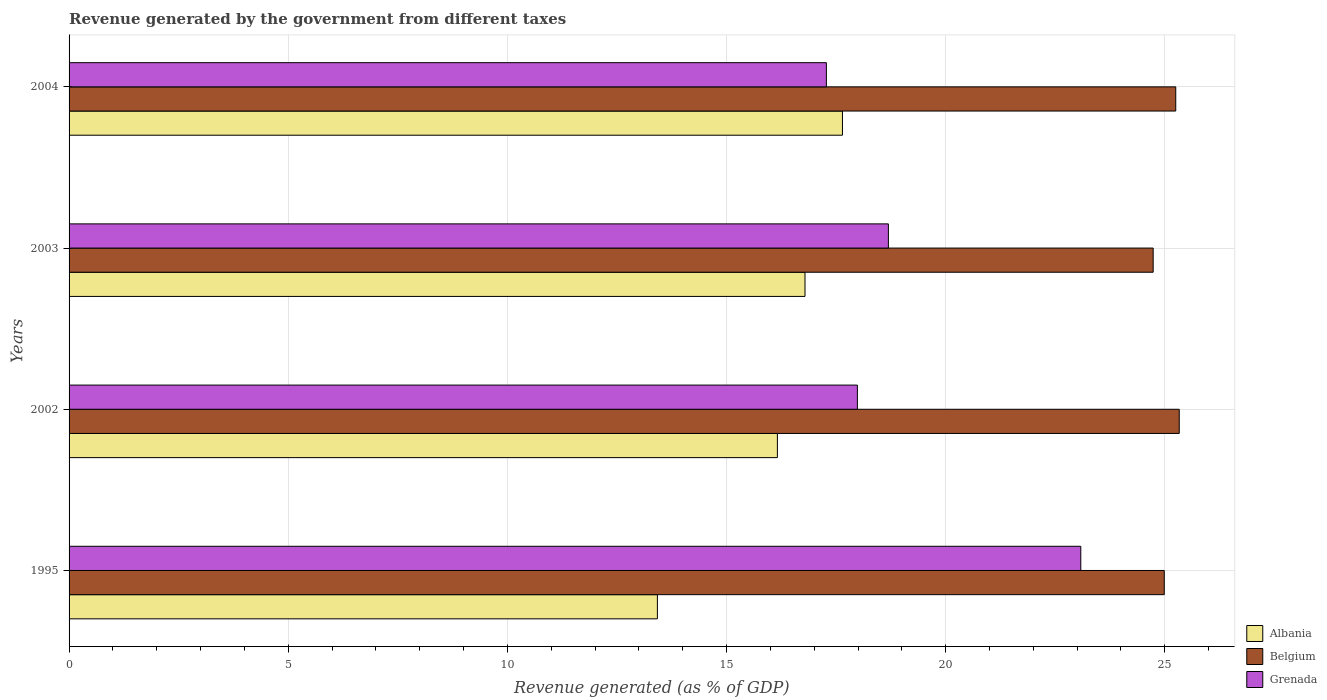How many groups of bars are there?
Offer a very short reply. 4. Are the number of bars per tick equal to the number of legend labels?
Provide a short and direct response. Yes. How many bars are there on the 3rd tick from the top?
Make the answer very short. 3. How many bars are there on the 4th tick from the bottom?
Your answer should be compact. 3. What is the label of the 2nd group of bars from the top?
Provide a succinct answer. 2003. What is the revenue generated by the government in Belgium in 2003?
Your response must be concise. 24.73. Across all years, what is the maximum revenue generated by the government in Grenada?
Keep it short and to the point. 23.08. Across all years, what is the minimum revenue generated by the government in Grenada?
Ensure brevity in your answer.  17.28. In which year was the revenue generated by the government in Belgium maximum?
Ensure brevity in your answer.  2002. What is the total revenue generated by the government in Albania in the graph?
Your response must be concise. 64.02. What is the difference between the revenue generated by the government in Grenada in 1995 and that in 2004?
Your answer should be very brief. 5.8. What is the difference between the revenue generated by the government in Albania in 2004 and the revenue generated by the government in Grenada in 2003?
Offer a very short reply. -1.05. What is the average revenue generated by the government in Grenada per year?
Your answer should be compact. 19.26. In the year 2002, what is the difference between the revenue generated by the government in Albania and revenue generated by the government in Belgium?
Provide a succinct answer. -9.17. In how many years, is the revenue generated by the government in Grenada greater than 2 %?
Give a very brief answer. 4. What is the ratio of the revenue generated by the government in Grenada in 2003 to that in 2004?
Offer a terse response. 1.08. What is the difference between the highest and the second highest revenue generated by the government in Belgium?
Your answer should be compact. 0.08. What is the difference between the highest and the lowest revenue generated by the government in Albania?
Make the answer very short. 4.22. Is the sum of the revenue generated by the government in Albania in 1995 and 2003 greater than the maximum revenue generated by the government in Belgium across all years?
Your response must be concise. Yes. What does the 1st bar from the top in 2002 represents?
Make the answer very short. Grenada. How many bars are there?
Make the answer very short. 12. How many years are there in the graph?
Your answer should be very brief. 4. What is the difference between two consecutive major ticks on the X-axis?
Your answer should be very brief. 5. Does the graph contain any zero values?
Your response must be concise. No. Does the graph contain grids?
Provide a succinct answer. Yes. How many legend labels are there?
Make the answer very short. 3. What is the title of the graph?
Your response must be concise. Revenue generated by the government from different taxes. What is the label or title of the X-axis?
Offer a very short reply. Revenue generated (as % of GDP). What is the Revenue generated (as % of GDP) in Albania in 1995?
Ensure brevity in your answer.  13.42. What is the Revenue generated (as % of GDP) of Belgium in 1995?
Offer a very short reply. 24.99. What is the Revenue generated (as % of GDP) in Grenada in 1995?
Ensure brevity in your answer.  23.08. What is the Revenue generated (as % of GDP) of Albania in 2002?
Ensure brevity in your answer.  16.16. What is the Revenue generated (as % of GDP) in Belgium in 2002?
Offer a very short reply. 25.33. What is the Revenue generated (as % of GDP) in Grenada in 2002?
Your answer should be very brief. 17.99. What is the Revenue generated (as % of GDP) in Albania in 2003?
Provide a short and direct response. 16.79. What is the Revenue generated (as % of GDP) in Belgium in 2003?
Ensure brevity in your answer.  24.73. What is the Revenue generated (as % of GDP) in Grenada in 2003?
Provide a short and direct response. 18.69. What is the Revenue generated (as % of GDP) of Albania in 2004?
Give a very brief answer. 17.65. What is the Revenue generated (as % of GDP) in Belgium in 2004?
Offer a terse response. 25.25. What is the Revenue generated (as % of GDP) in Grenada in 2004?
Your answer should be compact. 17.28. Across all years, what is the maximum Revenue generated (as % of GDP) of Albania?
Keep it short and to the point. 17.65. Across all years, what is the maximum Revenue generated (as % of GDP) of Belgium?
Make the answer very short. 25.33. Across all years, what is the maximum Revenue generated (as % of GDP) of Grenada?
Keep it short and to the point. 23.08. Across all years, what is the minimum Revenue generated (as % of GDP) of Albania?
Provide a succinct answer. 13.42. Across all years, what is the minimum Revenue generated (as % of GDP) of Belgium?
Give a very brief answer. 24.73. Across all years, what is the minimum Revenue generated (as % of GDP) in Grenada?
Ensure brevity in your answer.  17.28. What is the total Revenue generated (as % of GDP) of Albania in the graph?
Keep it short and to the point. 64.02. What is the total Revenue generated (as % of GDP) of Belgium in the graph?
Make the answer very short. 100.3. What is the total Revenue generated (as % of GDP) in Grenada in the graph?
Your response must be concise. 77.04. What is the difference between the Revenue generated (as % of GDP) of Albania in 1995 and that in 2002?
Offer a very short reply. -2.74. What is the difference between the Revenue generated (as % of GDP) of Belgium in 1995 and that in 2002?
Provide a short and direct response. -0.34. What is the difference between the Revenue generated (as % of GDP) of Grenada in 1995 and that in 2002?
Offer a terse response. 5.1. What is the difference between the Revenue generated (as % of GDP) of Albania in 1995 and that in 2003?
Ensure brevity in your answer.  -3.37. What is the difference between the Revenue generated (as % of GDP) of Belgium in 1995 and that in 2003?
Offer a very short reply. 0.25. What is the difference between the Revenue generated (as % of GDP) of Grenada in 1995 and that in 2003?
Provide a short and direct response. 4.39. What is the difference between the Revenue generated (as % of GDP) of Albania in 1995 and that in 2004?
Your response must be concise. -4.22. What is the difference between the Revenue generated (as % of GDP) in Belgium in 1995 and that in 2004?
Make the answer very short. -0.26. What is the difference between the Revenue generated (as % of GDP) in Grenada in 1995 and that in 2004?
Offer a terse response. 5.8. What is the difference between the Revenue generated (as % of GDP) of Albania in 2002 and that in 2003?
Your answer should be very brief. -0.63. What is the difference between the Revenue generated (as % of GDP) of Belgium in 2002 and that in 2003?
Your response must be concise. 0.59. What is the difference between the Revenue generated (as % of GDP) of Grenada in 2002 and that in 2003?
Your answer should be compact. -0.71. What is the difference between the Revenue generated (as % of GDP) in Albania in 2002 and that in 2004?
Your answer should be compact. -1.48. What is the difference between the Revenue generated (as % of GDP) in Belgium in 2002 and that in 2004?
Provide a short and direct response. 0.08. What is the difference between the Revenue generated (as % of GDP) of Grenada in 2002 and that in 2004?
Give a very brief answer. 0.71. What is the difference between the Revenue generated (as % of GDP) in Albania in 2003 and that in 2004?
Your answer should be very brief. -0.85. What is the difference between the Revenue generated (as % of GDP) of Belgium in 2003 and that in 2004?
Your response must be concise. -0.52. What is the difference between the Revenue generated (as % of GDP) of Grenada in 2003 and that in 2004?
Offer a very short reply. 1.41. What is the difference between the Revenue generated (as % of GDP) in Albania in 1995 and the Revenue generated (as % of GDP) in Belgium in 2002?
Give a very brief answer. -11.91. What is the difference between the Revenue generated (as % of GDP) of Albania in 1995 and the Revenue generated (as % of GDP) of Grenada in 2002?
Offer a very short reply. -4.56. What is the difference between the Revenue generated (as % of GDP) in Belgium in 1995 and the Revenue generated (as % of GDP) in Grenada in 2002?
Provide a succinct answer. 7. What is the difference between the Revenue generated (as % of GDP) in Albania in 1995 and the Revenue generated (as % of GDP) in Belgium in 2003?
Your answer should be very brief. -11.31. What is the difference between the Revenue generated (as % of GDP) in Albania in 1995 and the Revenue generated (as % of GDP) in Grenada in 2003?
Offer a terse response. -5.27. What is the difference between the Revenue generated (as % of GDP) of Belgium in 1995 and the Revenue generated (as % of GDP) of Grenada in 2003?
Provide a succinct answer. 6.29. What is the difference between the Revenue generated (as % of GDP) in Albania in 1995 and the Revenue generated (as % of GDP) in Belgium in 2004?
Make the answer very short. -11.83. What is the difference between the Revenue generated (as % of GDP) in Albania in 1995 and the Revenue generated (as % of GDP) in Grenada in 2004?
Your answer should be very brief. -3.86. What is the difference between the Revenue generated (as % of GDP) in Belgium in 1995 and the Revenue generated (as % of GDP) in Grenada in 2004?
Your response must be concise. 7.71. What is the difference between the Revenue generated (as % of GDP) in Albania in 2002 and the Revenue generated (as % of GDP) in Belgium in 2003?
Provide a short and direct response. -8.57. What is the difference between the Revenue generated (as % of GDP) in Albania in 2002 and the Revenue generated (as % of GDP) in Grenada in 2003?
Your answer should be compact. -2.53. What is the difference between the Revenue generated (as % of GDP) in Belgium in 2002 and the Revenue generated (as % of GDP) in Grenada in 2003?
Give a very brief answer. 6.64. What is the difference between the Revenue generated (as % of GDP) in Albania in 2002 and the Revenue generated (as % of GDP) in Belgium in 2004?
Provide a short and direct response. -9.09. What is the difference between the Revenue generated (as % of GDP) of Albania in 2002 and the Revenue generated (as % of GDP) of Grenada in 2004?
Make the answer very short. -1.12. What is the difference between the Revenue generated (as % of GDP) in Belgium in 2002 and the Revenue generated (as % of GDP) in Grenada in 2004?
Your response must be concise. 8.05. What is the difference between the Revenue generated (as % of GDP) of Albania in 2003 and the Revenue generated (as % of GDP) of Belgium in 2004?
Provide a succinct answer. -8.46. What is the difference between the Revenue generated (as % of GDP) of Albania in 2003 and the Revenue generated (as % of GDP) of Grenada in 2004?
Your answer should be very brief. -0.49. What is the difference between the Revenue generated (as % of GDP) in Belgium in 2003 and the Revenue generated (as % of GDP) in Grenada in 2004?
Your answer should be very brief. 7.46. What is the average Revenue generated (as % of GDP) in Albania per year?
Provide a short and direct response. 16. What is the average Revenue generated (as % of GDP) in Belgium per year?
Provide a succinct answer. 25.08. What is the average Revenue generated (as % of GDP) of Grenada per year?
Offer a very short reply. 19.26. In the year 1995, what is the difference between the Revenue generated (as % of GDP) of Albania and Revenue generated (as % of GDP) of Belgium?
Make the answer very short. -11.56. In the year 1995, what is the difference between the Revenue generated (as % of GDP) of Albania and Revenue generated (as % of GDP) of Grenada?
Make the answer very short. -9.66. In the year 1995, what is the difference between the Revenue generated (as % of GDP) of Belgium and Revenue generated (as % of GDP) of Grenada?
Provide a succinct answer. 1.9. In the year 2002, what is the difference between the Revenue generated (as % of GDP) of Albania and Revenue generated (as % of GDP) of Belgium?
Give a very brief answer. -9.17. In the year 2002, what is the difference between the Revenue generated (as % of GDP) of Albania and Revenue generated (as % of GDP) of Grenada?
Offer a very short reply. -1.83. In the year 2002, what is the difference between the Revenue generated (as % of GDP) of Belgium and Revenue generated (as % of GDP) of Grenada?
Offer a very short reply. 7.34. In the year 2003, what is the difference between the Revenue generated (as % of GDP) of Albania and Revenue generated (as % of GDP) of Belgium?
Offer a terse response. -7.94. In the year 2003, what is the difference between the Revenue generated (as % of GDP) in Albania and Revenue generated (as % of GDP) in Grenada?
Offer a very short reply. -1.9. In the year 2003, what is the difference between the Revenue generated (as % of GDP) of Belgium and Revenue generated (as % of GDP) of Grenada?
Provide a short and direct response. 6.04. In the year 2004, what is the difference between the Revenue generated (as % of GDP) of Albania and Revenue generated (as % of GDP) of Belgium?
Your answer should be compact. -7.6. In the year 2004, what is the difference between the Revenue generated (as % of GDP) in Albania and Revenue generated (as % of GDP) in Grenada?
Your answer should be compact. 0.37. In the year 2004, what is the difference between the Revenue generated (as % of GDP) of Belgium and Revenue generated (as % of GDP) of Grenada?
Your response must be concise. 7.97. What is the ratio of the Revenue generated (as % of GDP) in Albania in 1995 to that in 2002?
Keep it short and to the point. 0.83. What is the ratio of the Revenue generated (as % of GDP) in Belgium in 1995 to that in 2002?
Offer a terse response. 0.99. What is the ratio of the Revenue generated (as % of GDP) of Grenada in 1995 to that in 2002?
Ensure brevity in your answer.  1.28. What is the ratio of the Revenue generated (as % of GDP) in Albania in 1995 to that in 2003?
Offer a terse response. 0.8. What is the ratio of the Revenue generated (as % of GDP) in Belgium in 1995 to that in 2003?
Your answer should be compact. 1.01. What is the ratio of the Revenue generated (as % of GDP) in Grenada in 1995 to that in 2003?
Your response must be concise. 1.23. What is the ratio of the Revenue generated (as % of GDP) of Albania in 1995 to that in 2004?
Your answer should be very brief. 0.76. What is the ratio of the Revenue generated (as % of GDP) in Belgium in 1995 to that in 2004?
Give a very brief answer. 0.99. What is the ratio of the Revenue generated (as % of GDP) in Grenada in 1995 to that in 2004?
Provide a short and direct response. 1.34. What is the ratio of the Revenue generated (as % of GDP) of Albania in 2002 to that in 2003?
Your answer should be compact. 0.96. What is the ratio of the Revenue generated (as % of GDP) of Belgium in 2002 to that in 2003?
Make the answer very short. 1.02. What is the ratio of the Revenue generated (as % of GDP) in Grenada in 2002 to that in 2003?
Make the answer very short. 0.96. What is the ratio of the Revenue generated (as % of GDP) of Albania in 2002 to that in 2004?
Ensure brevity in your answer.  0.92. What is the ratio of the Revenue generated (as % of GDP) in Belgium in 2002 to that in 2004?
Give a very brief answer. 1. What is the ratio of the Revenue generated (as % of GDP) in Grenada in 2002 to that in 2004?
Your answer should be very brief. 1.04. What is the ratio of the Revenue generated (as % of GDP) of Albania in 2003 to that in 2004?
Offer a terse response. 0.95. What is the ratio of the Revenue generated (as % of GDP) in Belgium in 2003 to that in 2004?
Provide a succinct answer. 0.98. What is the ratio of the Revenue generated (as % of GDP) of Grenada in 2003 to that in 2004?
Make the answer very short. 1.08. What is the difference between the highest and the second highest Revenue generated (as % of GDP) of Albania?
Give a very brief answer. 0.85. What is the difference between the highest and the second highest Revenue generated (as % of GDP) of Belgium?
Make the answer very short. 0.08. What is the difference between the highest and the second highest Revenue generated (as % of GDP) in Grenada?
Your response must be concise. 4.39. What is the difference between the highest and the lowest Revenue generated (as % of GDP) of Albania?
Your answer should be compact. 4.22. What is the difference between the highest and the lowest Revenue generated (as % of GDP) in Belgium?
Your answer should be compact. 0.59. What is the difference between the highest and the lowest Revenue generated (as % of GDP) of Grenada?
Your answer should be very brief. 5.8. 